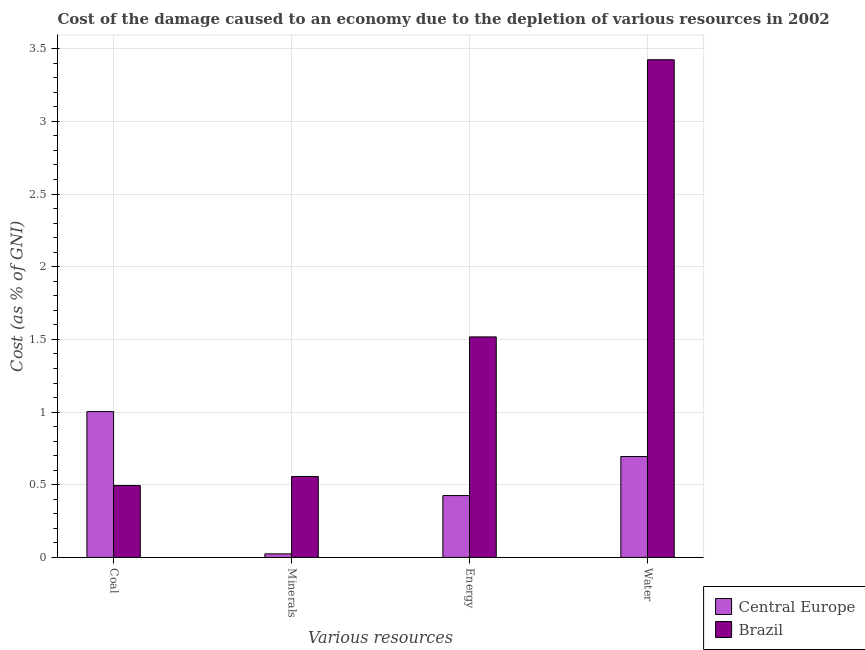How many groups of bars are there?
Give a very brief answer. 4. What is the label of the 1st group of bars from the left?
Your answer should be compact. Coal. What is the cost of damage due to depletion of coal in Brazil?
Provide a succinct answer. 0.49. Across all countries, what is the maximum cost of damage due to depletion of energy?
Give a very brief answer. 1.52. Across all countries, what is the minimum cost of damage due to depletion of energy?
Provide a short and direct response. 0.43. In which country was the cost of damage due to depletion of minerals maximum?
Keep it short and to the point. Brazil. In which country was the cost of damage due to depletion of water minimum?
Ensure brevity in your answer.  Central Europe. What is the total cost of damage due to depletion of minerals in the graph?
Offer a very short reply. 0.58. What is the difference between the cost of damage due to depletion of minerals in Central Europe and that in Brazil?
Keep it short and to the point. -0.53. What is the difference between the cost of damage due to depletion of water in Brazil and the cost of damage due to depletion of energy in Central Europe?
Your answer should be compact. 3. What is the average cost of damage due to depletion of minerals per country?
Your response must be concise. 0.29. What is the difference between the cost of damage due to depletion of minerals and cost of damage due to depletion of coal in Brazil?
Ensure brevity in your answer.  0.06. In how many countries, is the cost of damage due to depletion of water greater than 2.7 %?
Your answer should be very brief. 1. What is the ratio of the cost of damage due to depletion of water in Brazil to that in Central Europe?
Offer a very short reply. 4.93. Is the cost of damage due to depletion of minerals in Brazil less than that in Central Europe?
Offer a terse response. No. What is the difference between the highest and the second highest cost of damage due to depletion of coal?
Your response must be concise. 0.51. What is the difference between the highest and the lowest cost of damage due to depletion of water?
Make the answer very short. 2.73. What does the 1st bar from the left in Energy represents?
Make the answer very short. Central Europe. Does the graph contain any zero values?
Keep it short and to the point. No. How many legend labels are there?
Provide a succinct answer. 2. How are the legend labels stacked?
Your response must be concise. Vertical. What is the title of the graph?
Keep it short and to the point. Cost of the damage caused to an economy due to the depletion of various resources in 2002 . What is the label or title of the X-axis?
Offer a very short reply. Various resources. What is the label or title of the Y-axis?
Keep it short and to the point. Cost (as % of GNI). What is the Cost (as % of GNI) in Central Europe in Coal?
Your answer should be compact. 1. What is the Cost (as % of GNI) of Brazil in Coal?
Your answer should be compact. 0.49. What is the Cost (as % of GNI) of Central Europe in Minerals?
Your response must be concise. 0.02. What is the Cost (as % of GNI) of Brazil in Minerals?
Your answer should be compact. 0.56. What is the Cost (as % of GNI) of Central Europe in Energy?
Keep it short and to the point. 0.43. What is the Cost (as % of GNI) of Brazil in Energy?
Provide a short and direct response. 1.52. What is the Cost (as % of GNI) of Central Europe in Water?
Provide a succinct answer. 0.69. What is the Cost (as % of GNI) of Brazil in Water?
Provide a short and direct response. 3.42. Across all Various resources, what is the maximum Cost (as % of GNI) in Central Europe?
Your response must be concise. 1. Across all Various resources, what is the maximum Cost (as % of GNI) of Brazil?
Make the answer very short. 3.42. Across all Various resources, what is the minimum Cost (as % of GNI) of Central Europe?
Give a very brief answer. 0.02. Across all Various resources, what is the minimum Cost (as % of GNI) in Brazil?
Make the answer very short. 0.49. What is the total Cost (as % of GNI) of Central Europe in the graph?
Provide a short and direct response. 2.15. What is the total Cost (as % of GNI) in Brazil in the graph?
Give a very brief answer. 5.99. What is the difference between the Cost (as % of GNI) in Central Europe in Coal and that in Minerals?
Keep it short and to the point. 0.98. What is the difference between the Cost (as % of GNI) of Brazil in Coal and that in Minerals?
Your response must be concise. -0.06. What is the difference between the Cost (as % of GNI) in Central Europe in Coal and that in Energy?
Give a very brief answer. 0.58. What is the difference between the Cost (as % of GNI) of Brazil in Coal and that in Energy?
Make the answer very short. -1.02. What is the difference between the Cost (as % of GNI) in Central Europe in Coal and that in Water?
Your answer should be compact. 0.31. What is the difference between the Cost (as % of GNI) in Brazil in Coal and that in Water?
Provide a succinct answer. -2.93. What is the difference between the Cost (as % of GNI) of Central Europe in Minerals and that in Energy?
Offer a very short reply. -0.4. What is the difference between the Cost (as % of GNI) of Brazil in Minerals and that in Energy?
Provide a short and direct response. -0.96. What is the difference between the Cost (as % of GNI) in Central Europe in Minerals and that in Water?
Provide a short and direct response. -0.67. What is the difference between the Cost (as % of GNI) of Brazil in Minerals and that in Water?
Your response must be concise. -2.87. What is the difference between the Cost (as % of GNI) in Central Europe in Energy and that in Water?
Your answer should be compact. -0.27. What is the difference between the Cost (as % of GNI) of Brazil in Energy and that in Water?
Ensure brevity in your answer.  -1.91. What is the difference between the Cost (as % of GNI) in Central Europe in Coal and the Cost (as % of GNI) in Brazil in Minerals?
Your answer should be compact. 0.45. What is the difference between the Cost (as % of GNI) of Central Europe in Coal and the Cost (as % of GNI) of Brazil in Energy?
Keep it short and to the point. -0.51. What is the difference between the Cost (as % of GNI) of Central Europe in Coal and the Cost (as % of GNI) of Brazil in Water?
Provide a short and direct response. -2.42. What is the difference between the Cost (as % of GNI) in Central Europe in Minerals and the Cost (as % of GNI) in Brazil in Energy?
Offer a very short reply. -1.49. What is the difference between the Cost (as % of GNI) in Central Europe in Minerals and the Cost (as % of GNI) in Brazil in Water?
Offer a terse response. -3.4. What is the difference between the Cost (as % of GNI) of Central Europe in Energy and the Cost (as % of GNI) of Brazil in Water?
Your answer should be compact. -3. What is the average Cost (as % of GNI) of Central Europe per Various resources?
Give a very brief answer. 0.54. What is the average Cost (as % of GNI) in Brazil per Various resources?
Give a very brief answer. 1.5. What is the difference between the Cost (as % of GNI) in Central Europe and Cost (as % of GNI) in Brazil in Coal?
Provide a succinct answer. 0.51. What is the difference between the Cost (as % of GNI) of Central Europe and Cost (as % of GNI) of Brazil in Minerals?
Your response must be concise. -0.53. What is the difference between the Cost (as % of GNI) of Central Europe and Cost (as % of GNI) of Brazil in Energy?
Ensure brevity in your answer.  -1.09. What is the difference between the Cost (as % of GNI) of Central Europe and Cost (as % of GNI) of Brazil in Water?
Your response must be concise. -2.73. What is the ratio of the Cost (as % of GNI) of Central Europe in Coal to that in Minerals?
Make the answer very short. 40.89. What is the ratio of the Cost (as % of GNI) in Brazil in Coal to that in Minerals?
Your answer should be very brief. 0.89. What is the ratio of the Cost (as % of GNI) in Central Europe in Coal to that in Energy?
Your response must be concise. 2.36. What is the ratio of the Cost (as % of GNI) of Brazil in Coal to that in Energy?
Your answer should be very brief. 0.33. What is the ratio of the Cost (as % of GNI) in Central Europe in Coal to that in Water?
Keep it short and to the point. 1.45. What is the ratio of the Cost (as % of GNI) of Brazil in Coal to that in Water?
Ensure brevity in your answer.  0.14. What is the ratio of the Cost (as % of GNI) in Central Europe in Minerals to that in Energy?
Provide a succinct answer. 0.06. What is the ratio of the Cost (as % of GNI) in Brazil in Minerals to that in Energy?
Keep it short and to the point. 0.37. What is the ratio of the Cost (as % of GNI) in Central Europe in Minerals to that in Water?
Keep it short and to the point. 0.04. What is the ratio of the Cost (as % of GNI) in Brazil in Minerals to that in Water?
Your response must be concise. 0.16. What is the ratio of the Cost (as % of GNI) in Central Europe in Energy to that in Water?
Make the answer very short. 0.61. What is the ratio of the Cost (as % of GNI) in Brazil in Energy to that in Water?
Your answer should be very brief. 0.44. What is the difference between the highest and the second highest Cost (as % of GNI) in Central Europe?
Offer a terse response. 0.31. What is the difference between the highest and the second highest Cost (as % of GNI) of Brazil?
Offer a very short reply. 1.91. What is the difference between the highest and the lowest Cost (as % of GNI) in Central Europe?
Ensure brevity in your answer.  0.98. What is the difference between the highest and the lowest Cost (as % of GNI) of Brazil?
Ensure brevity in your answer.  2.93. 